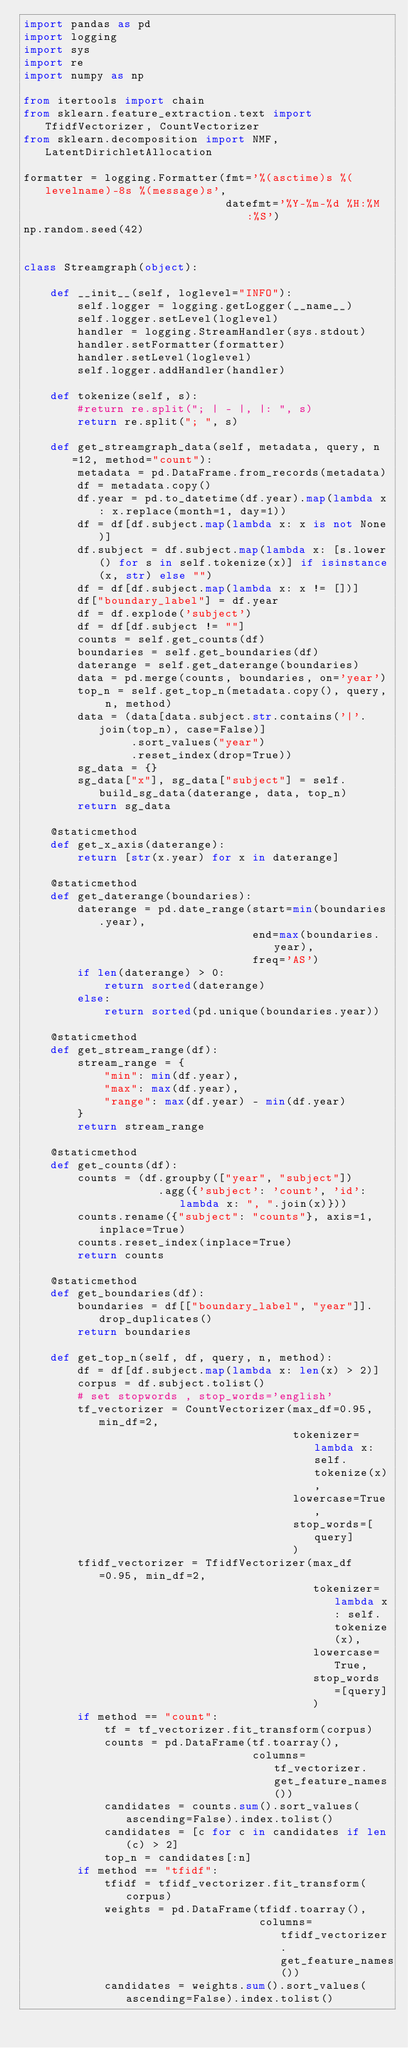<code> <loc_0><loc_0><loc_500><loc_500><_Python_>import pandas as pd
import logging
import sys
import re
import numpy as np

from itertools import chain
from sklearn.feature_extraction.text import TfidfVectorizer, CountVectorizer
from sklearn.decomposition import NMF, LatentDirichletAllocation

formatter = logging.Formatter(fmt='%(asctime)s %(levelname)-8s %(message)s',
                              datefmt='%Y-%m-%d %H:%M:%S')
np.random.seed(42)


class Streamgraph(object):

    def __init__(self, loglevel="INFO"):
        self.logger = logging.getLogger(__name__)
        self.logger.setLevel(loglevel)
        handler = logging.StreamHandler(sys.stdout)
        handler.setFormatter(formatter)
        handler.setLevel(loglevel)
        self.logger.addHandler(handler)
    
    def tokenize(self, s):
        #return re.split("; | - |, |: ", s)
        return re.split("; ", s)

    def get_streamgraph_data(self, metadata, query, n=12, method="count"):
        metadata = pd.DataFrame.from_records(metadata)
        df = metadata.copy()
        df.year = pd.to_datetime(df.year).map(lambda x: x.replace(month=1, day=1))
        df = df[df.subject.map(lambda x: x is not None)]
        df.subject = df.subject.map(lambda x: [s.lower() for s in self.tokenize(x)] if isinstance(x, str) else "")
        df = df[df.subject.map(lambda x: x != [])]
        df["boundary_label"] = df.year
        df = df.explode('subject')
        df = df[df.subject != ""]
        counts = self.get_counts(df)
        boundaries = self.get_boundaries(df)
        daterange = self.get_daterange(boundaries)
        data = pd.merge(counts, boundaries, on='year')
        top_n = self.get_top_n(metadata.copy(), query, n, method)
        data = (data[data.subject.str.contains('|'.join(top_n), case=False)]
                .sort_values("year")
                .reset_index(drop=True))
        sg_data = {}
        sg_data["x"], sg_data["subject"] = self.build_sg_data(daterange, data, top_n)
        return sg_data

    @staticmethod
    def get_x_axis(daterange):
        return [str(x.year) for x in daterange]

    @staticmethod
    def get_daterange(boundaries):
        daterange = pd.date_range(start=min(boundaries.year),
                                  end=max(boundaries.year),
                                  freq='AS')
        if len(daterange) > 0:
            return sorted(daterange)
        else:
            return sorted(pd.unique(boundaries.year))

    @staticmethod
    def get_stream_range(df):
        stream_range = {
            "min": min(df.year),
            "max": max(df.year),
            "range": max(df.year) - min(df.year)
        }
        return stream_range

    @staticmethod
    def get_counts(df):
        counts = (df.groupby(["year", "subject"])
                    .agg({'subject': 'count', 'id': lambda x: ", ".join(x)}))
        counts.rename({"subject": "counts"}, axis=1, inplace=True)
        counts.reset_index(inplace=True)
        return counts

    @staticmethod
    def get_boundaries(df):
        boundaries = df[["boundary_label", "year"]].drop_duplicates()
        return boundaries

    def get_top_n(self, df, query, n, method):
        df = df[df.subject.map(lambda x: len(x) > 2)]
        corpus = df.subject.tolist()
        # set stopwords , stop_words='english'
        tf_vectorizer = CountVectorizer(max_df=0.95, min_df=2,
                                        tokenizer=lambda x: self.tokenize(x),
                                        lowercase=True,
                                        stop_words=[query]
                                        )
        tfidf_vectorizer = TfidfVectorizer(max_df=0.95, min_df=2,
                                           tokenizer=lambda x: self.tokenize(x),
                                           lowercase=True,
                                           stop_words=[query]
                                           )
        if method == "count":
            tf = tf_vectorizer.fit_transform(corpus)
            counts = pd.DataFrame(tf.toarray(),
                                  columns=tf_vectorizer.get_feature_names())
            candidates = counts.sum().sort_values(ascending=False).index.tolist()
            candidates = [c for c in candidates if len(c) > 2]
            top_n = candidates[:n]
        if method == "tfidf":
            tfidf = tfidf_vectorizer.fit_transform(corpus)
            weights = pd.DataFrame(tfidf.toarray(),
                                   columns=tfidf_vectorizer.get_feature_names())
            candidates = weights.sum().sort_values(ascending=False).index.tolist()</code> 